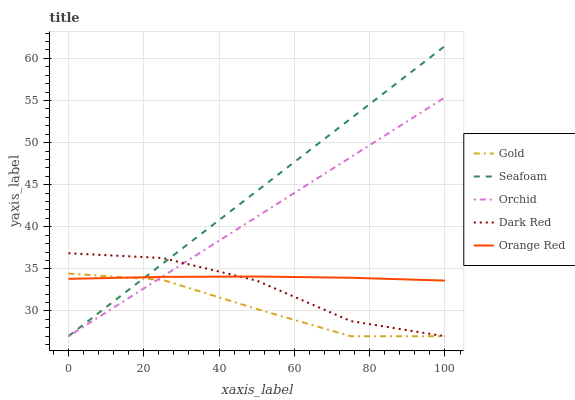Does Gold have the minimum area under the curve?
Answer yes or no. Yes. Does Seafoam have the maximum area under the curve?
Answer yes or no. Yes. Does Orange Red have the minimum area under the curve?
Answer yes or no. No. Does Orange Red have the maximum area under the curve?
Answer yes or no. No. Is Seafoam the smoothest?
Answer yes or no. Yes. Is Dark Red the roughest?
Answer yes or no. Yes. Is Orange Red the smoothest?
Answer yes or no. No. Is Orange Red the roughest?
Answer yes or no. No. Does Dark Red have the lowest value?
Answer yes or no. Yes. Does Orange Red have the lowest value?
Answer yes or no. No. Does Seafoam have the highest value?
Answer yes or no. Yes. Does Orange Red have the highest value?
Answer yes or no. No. Does Orchid intersect Orange Red?
Answer yes or no. Yes. Is Orchid less than Orange Red?
Answer yes or no. No. Is Orchid greater than Orange Red?
Answer yes or no. No. 